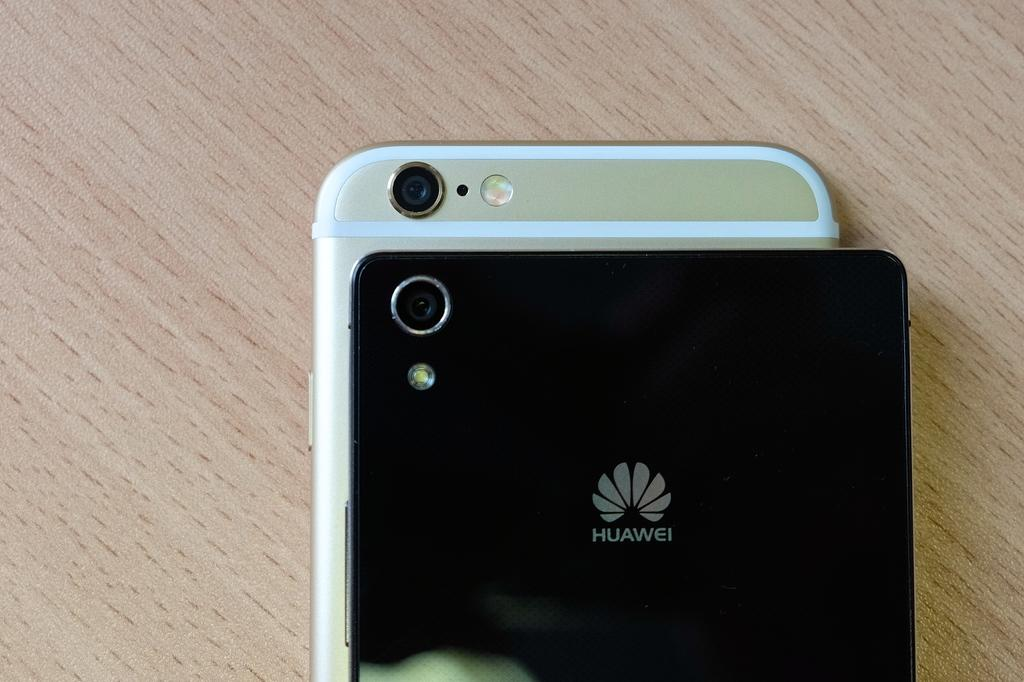<image>
Create a compact narrative representing the image presented. The back of a cellphone with a logo that reads Huawei on a desk 